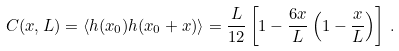Convert formula to latex. <formula><loc_0><loc_0><loc_500><loc_500>C ( x , L ) = \langle h ( x _ { 0 } ) h ( x _ { 0 } + x ) \rangle = \frac { L } { 1 2 } \left [ 1 - \frac { 6 x } { L } \left ( 1 - \frac { x } { L } \right ) \right ] \, .</formula> 